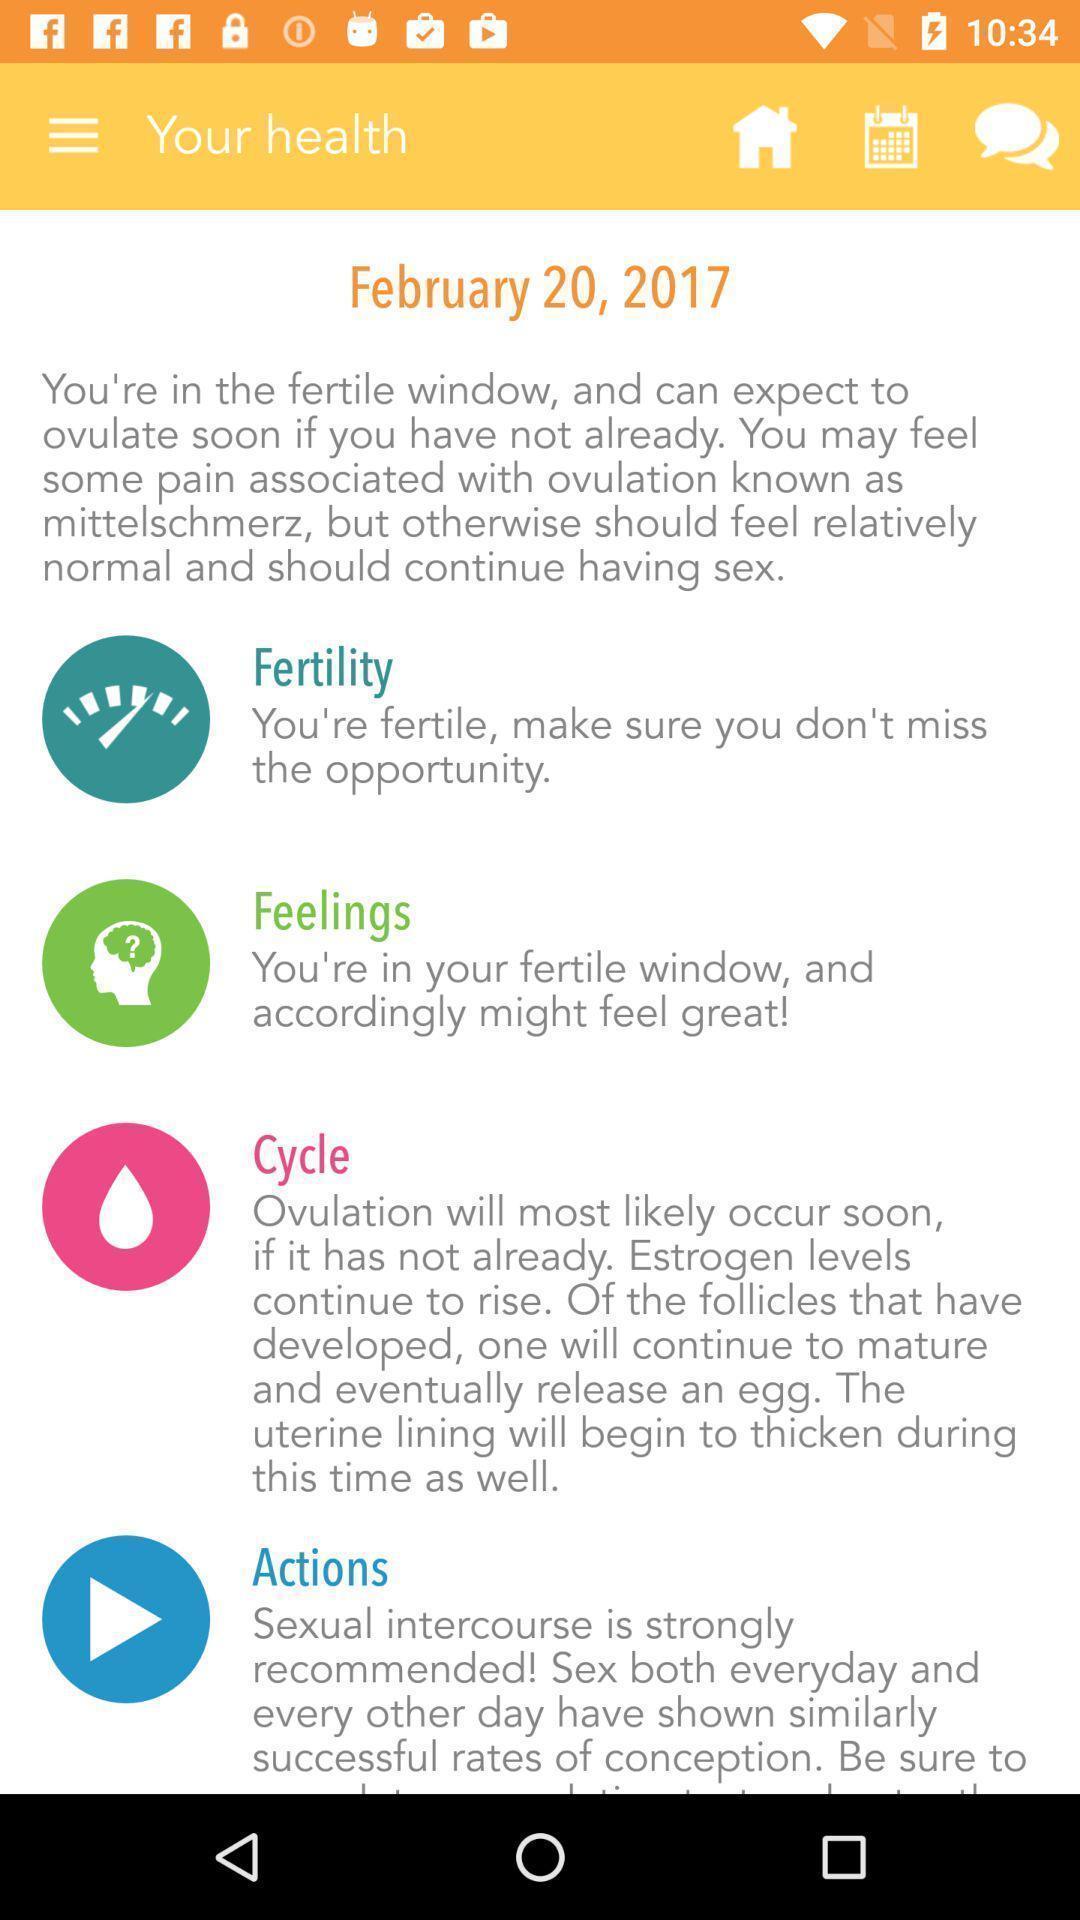Describe this image in words. Screen displaying the screen page of a period tracker app. 